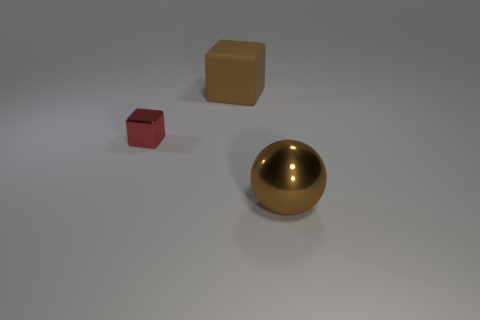Add 1 big shiny objects. How many objects exist? 4 Subtract all blocks. How many objects are left? 1 Subtract 0 red cylinders. How many objects are left? 3 Subtract all small shiny blocks. Subtract all large brown shiny things. How many objects are left? 1 Add 2 small shiny blocks. How many small shiny blocks are left? 3 Add 3 brown metallic balls. How many brown metallic balls exist? 4 